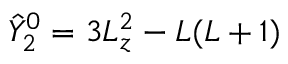Convert formula to latex. <formula><loc_0><loc_0><loc_500><loc_500>\hat { Y } _ { 2 } ^ { 0 } = 3 L _ { z } ^ { 2 } - L ( L + 1 )</formula> 